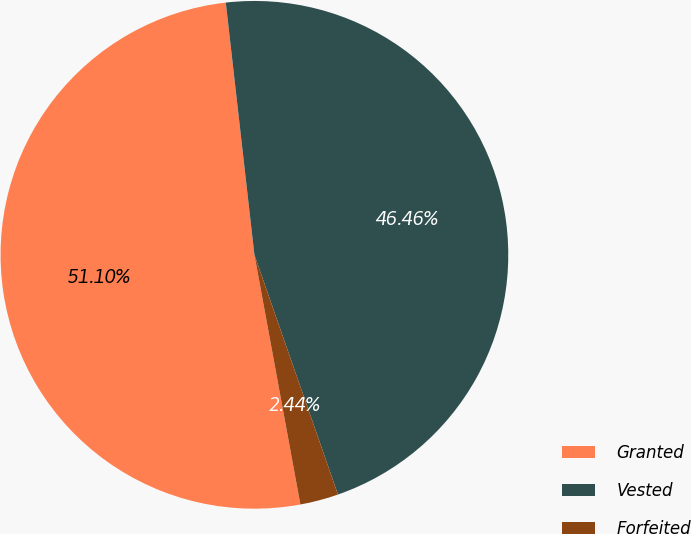<chart> <loc_0><loc_0><loc_500><loc_500><pie_chart><fcel>Granted<fcel>Vested<fcel>Forfeited<nl><fcel>51.1%<fcel>46.46%<fcel>2.44%<nl></chart> 